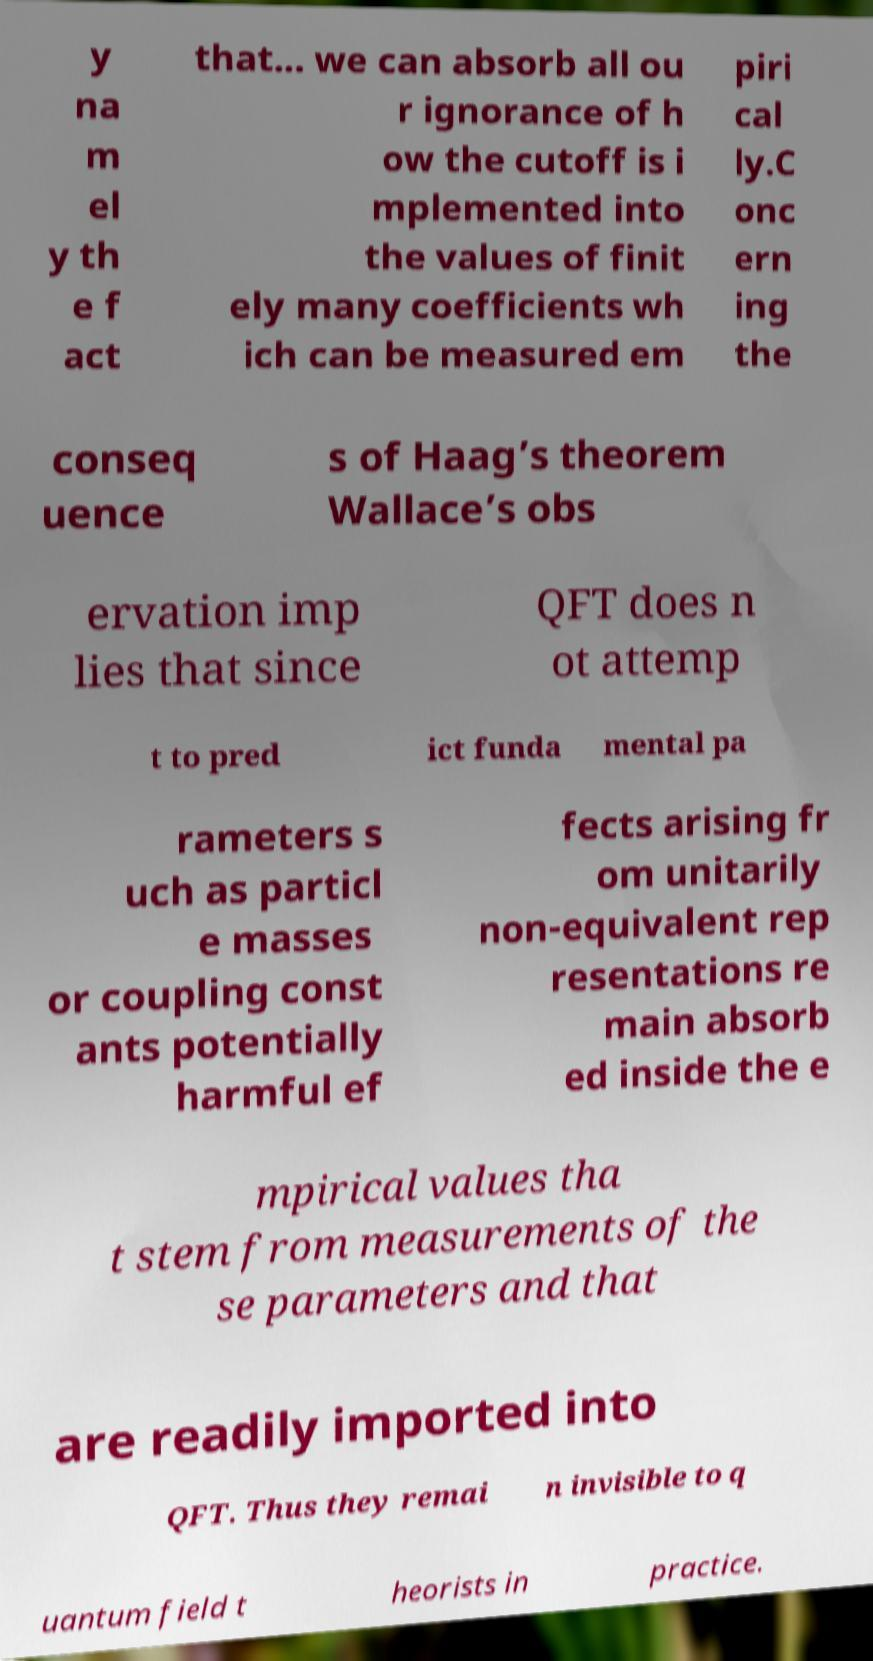Please read and relay the text visible in this image. What does it say? y na m el y th e f act that... we can absorb all ou r ignorance of h ow the cutoff is i mplemented into the values of finit ely many coefficients wh ich can be measured em piri cal ly.C onc ern ing the conseq uence s of Haag’s theorem Wallace’s obs ervation imp lies that since QFT does n ot attemp t to pred ict funda mental pa rameters s uch as particl e masses or coupling const ants potentially harmful ef fects arising fr om unitarily non-equivalent rep resentations re main absorb ed inside the e mpirical values tha t stem from measurements of the se parameters and that are readily imported into QFT. Thus they remai n invisible to q uantum field t heorists in practice. 